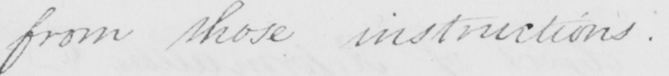Can you read and transcribe this handwriting? from those instructions . 